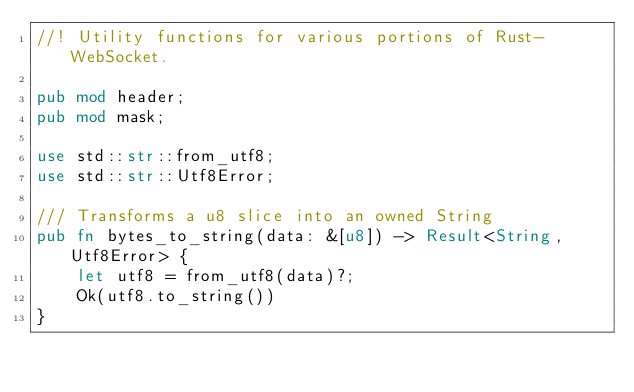<code> <loc_0><loc_0><loc_500><loc_500><_Rust_>//! Utility functions for various portions of Rust-WebSocket.

pub mod header;
pub mod mask;

use std::str::from_utf8;
use std::str::Utf8Error;

/// Transforms a u8 slice into an owned String
pub fn bytes_to_string(data: &[u8]) -> Result<String, Utf8Error> {
    let utf8 = from_utf8(data)?;
    Ok(utf8.to_string())
}
</code> 